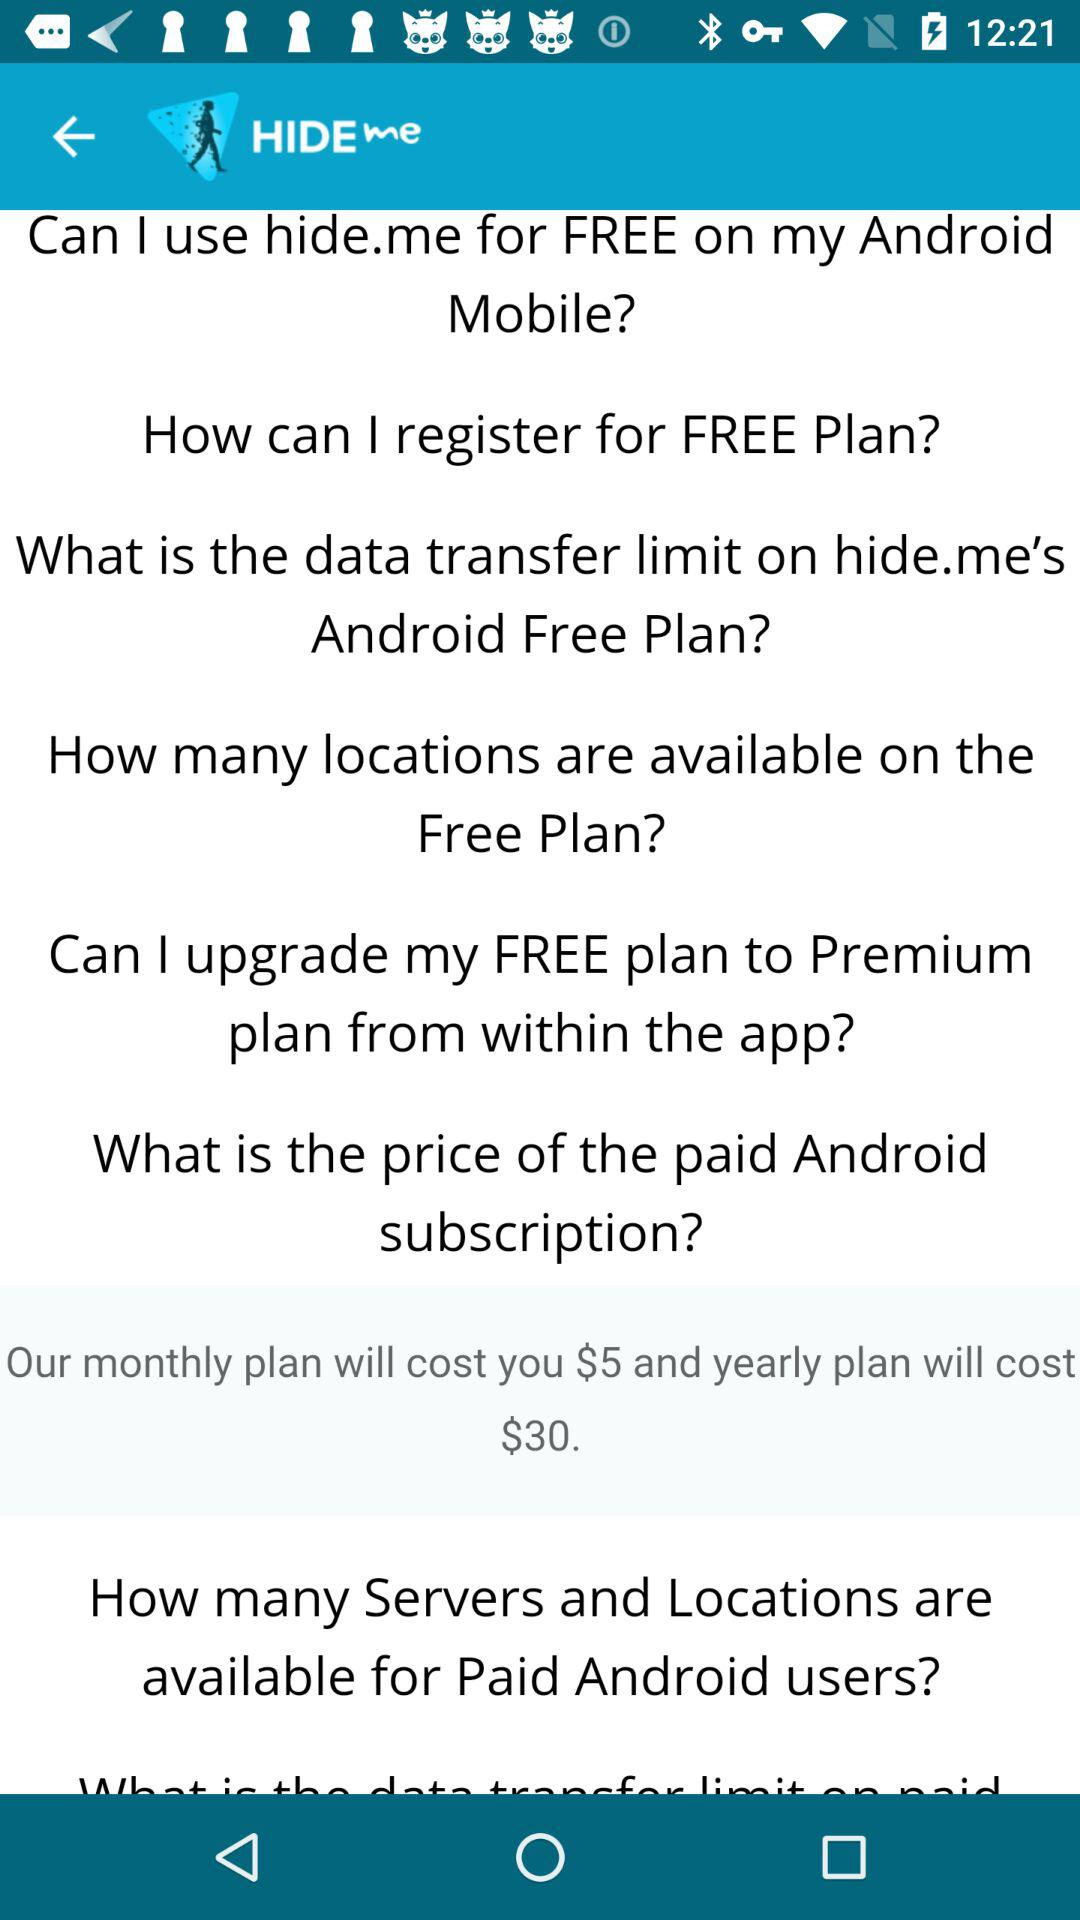How can the user register for a free plan?
When the provided information is insufficient, respond with <no answer>. <no answer> 